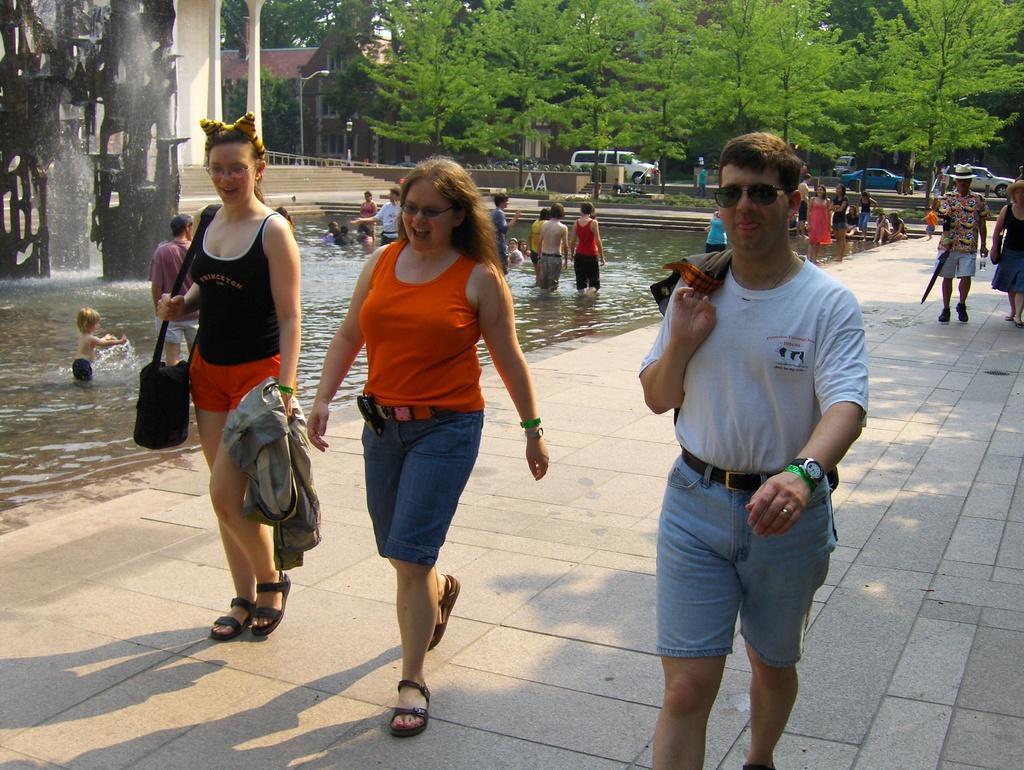How would you summarize this image in a sentence or two? In this image, we can see few people are walking on the walkway. Few are holding some objects. Background we can see water. Few people are in the water. Here few vehicles, trees, building, street light, pillar, stairs we can see. 